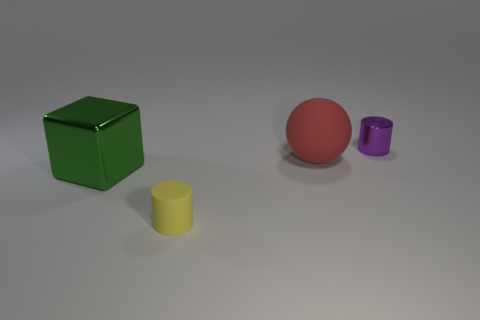What number of large objects are the same color as the tiny metallic cylinder?
Provide a short and direct response. 0. What number of things are either large objects behind the cube or shiny things that are to the left of the yellow matte thing?
Your response must be concise. 2. Is the number of large red matte spheres greater than the number of small green metal balls?
Offer a very short reply. Yes. There is a cylinder in front of the tiny purple object; what color is it?
Your response must be concise. Yellow. Does the red matte thing have the same shape as the large shiny object?
Keep it short and to the point. No. There is a object that is both in front of the tiny metallic object and to the right of the small yellow thing; what color is it?
Keep it short and to the point. Red. Does the ball in front of the purple shiny cylinder have the same size as the matte object in front of the large green metal cube?
Your response must be concise. No. How many things are either small cylinders that are behind the yellow rubber cylinder or large things?
Your answer should be very brief. 3. What is the yellow cylinder made of?
Your answer should be very brief. Rubber. Is the size of the red object the same as the purple shiny cylinder?
Provide a short and direct response. No. 